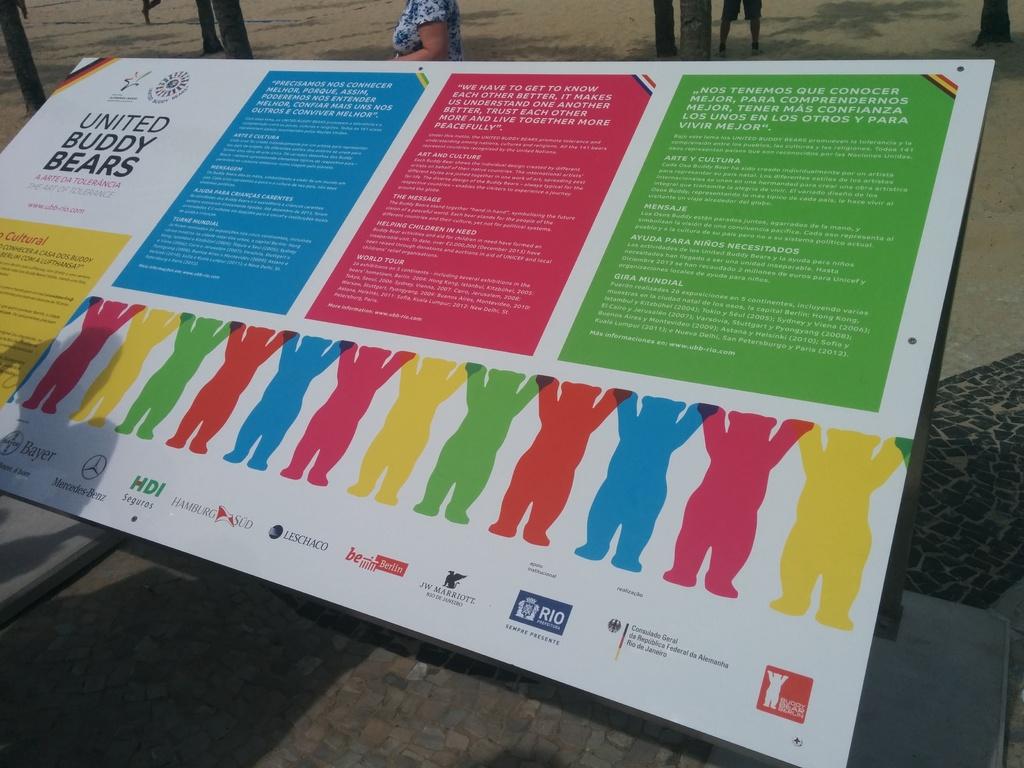What is this program called?
Ensure brevity in your answer.  United buddy bears. Who is the sponsor second to the left at the bottom?
Your answer should be very brief. Mercedes. 